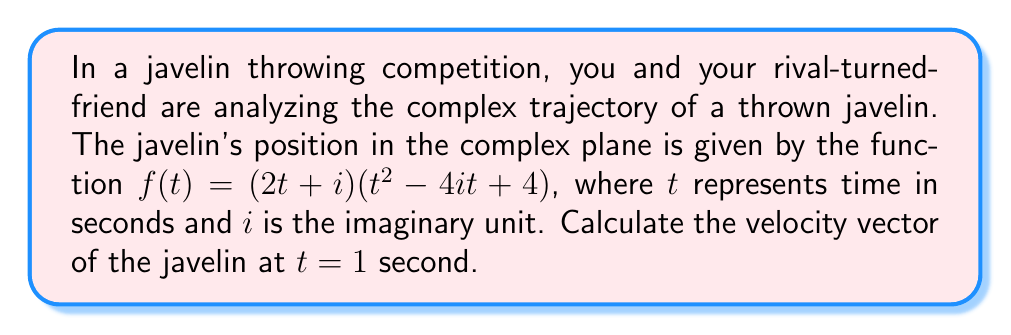Solve this math problem. To find the velocity vector at $t = 1$, we need to calculate the derivative of the position function $f(t)$ and evaluate it at $t = 1$. Let's break this down step-by-step:

1) First, let's expand the given function:
   $f(t) = (2t + i)(t^2 - 4it + 4)$
   $f(t) = 2t^3 - 8it^2 + 8t + it^2 - 4i^2t + 4i$
   $f(t) = 2t^3 + (i-8i)t^2 + (8+4)t + 4i$
   $f(t) = 2t^3 - 7it^2 + 12t + 4i$

2) Now, we need to find $f'(t)$:
   $f'(t) = 6t^2 - 14it + 12$

3) Evaluate $f'(t)$ at $t = 1$:
   $f'(1) = 6(1)^2 - 14i(1) + 12$
   $f'(1) = 6 - 14i + 12$
   $f'(1) = 18 - 14i$

4) This complex number represents the velocity vector at $t = 1$. 
   The real part (18) represents the horizontal component of the velocity,
   and the imaginary part (-14) represents the vertical component.

5) We can express this in the form $a + bi$:
   $v(1) = 18 - 14i$

This result gives us the instantaneous velocity of the javelin at $t = 1$ second in the complex plane.
Answer: $v(1) = 18 - 14i$ 